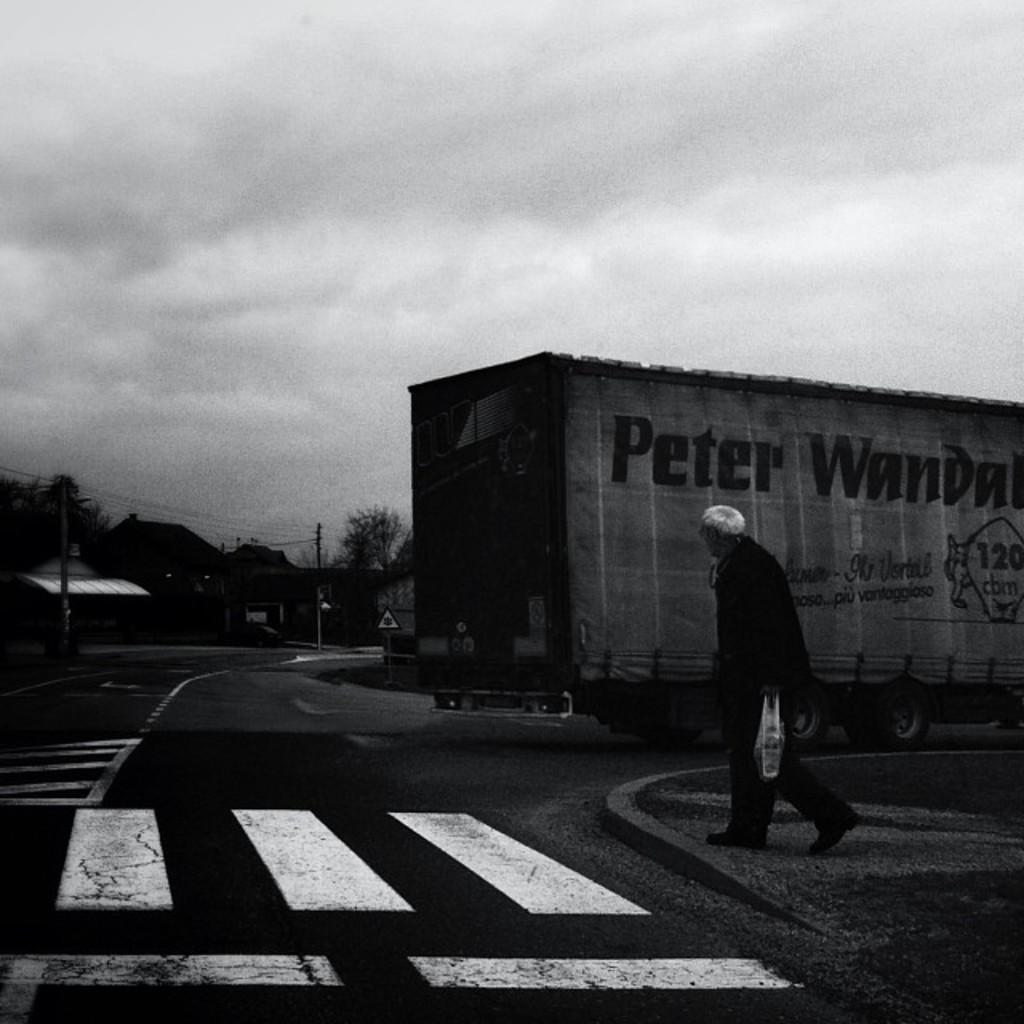Could you give a brief overview of what you see in this image? This is a black and white image, in this image on the right side there is one person who is holding some cover and walking. In the background there is a vehicle, houses, trees, poles and some wires. At the bottom there is a road and at the top of the image there is sky. 